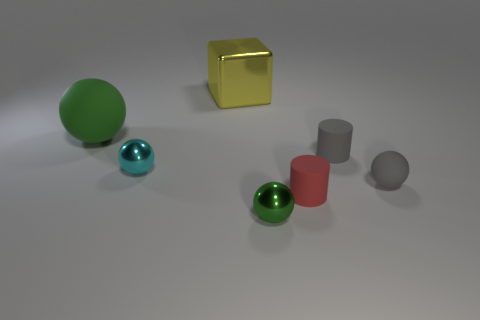Add 1 tiny cyan shiny spheres. How many objects exist? 8 Subtract all balls. How many objects are left? 3 Add 1 big things. How many big things exist? 3 Subtract 0 blue cubes. How many objects are left? 7 Subtract all small gray rubber objects. Subtract all large yellow things. How many objects are left? 4 Add 7 large green matte spheres. How many large green matte spheres are left? 8 